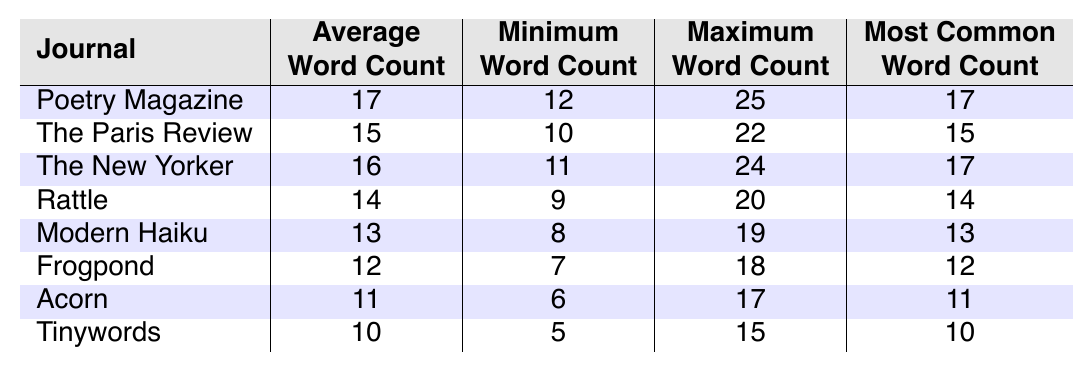What is the average word count for haiku published in Poetry Magazine? The table shows "Average Word Count" for Poetry Magazine is 17.
Answer: 17 What is the minimum word count among the haiku published in Tinywords? For Tinywords, the table lists the "Minimum Word Count" as 5.
Answer: 5 Which journal has the highest maximum word count, and what is that count? The table indicates that "Poetry Magazine" has the highest "Maximum Word Count" of 25.
Answer: Poetry Magazine, 25 Is the most common word count for Rattle higher than that for Acorn? The table shows that Rattle's "Most Common Word Count" is 14 and Acorn's is 11, thus 14 > 11 is true.
Answer: Yes What is the difference between the average word count of The New Yorker and Frogpond? The average word count for The New Yorker is 16, and for Frogpond it is 12; the difference is 16 - 12 = 4.
Answer: 4 How many journals have an average word count greater than or equal to 15? By reviewing the 'Average Word Count' column, there are 4 journals (Poetry Magazine, The New Yorker, The Paris Review, and Rattle) with counts 15 or above.
Answer: 4 What is the smallest maximum word count recorded for any of the journals? The table lists Tinywords as having the smallest "Maximum Word Count" of 15.
Answer: 15 If we take the average word counts of all journals, what is that overall average? Average word counts are 17, 15, 16, 14, 13, 12, 11, 10. The sum is 88, and there are 8 journals, so the overall average is 88 / 8 = 11.
Answer: 11 How does the most common word count for Modern Haiku compare to its average word count? Modern Haiku has an average of 13 and a most common count of 13, meaning they are equal.
Answer: They are equal Which journal has the lowest average word count and what is it? The table indicates that Tinywords has the lowest "Average Word Count" of 10.
Answer: Tinywords, 10 